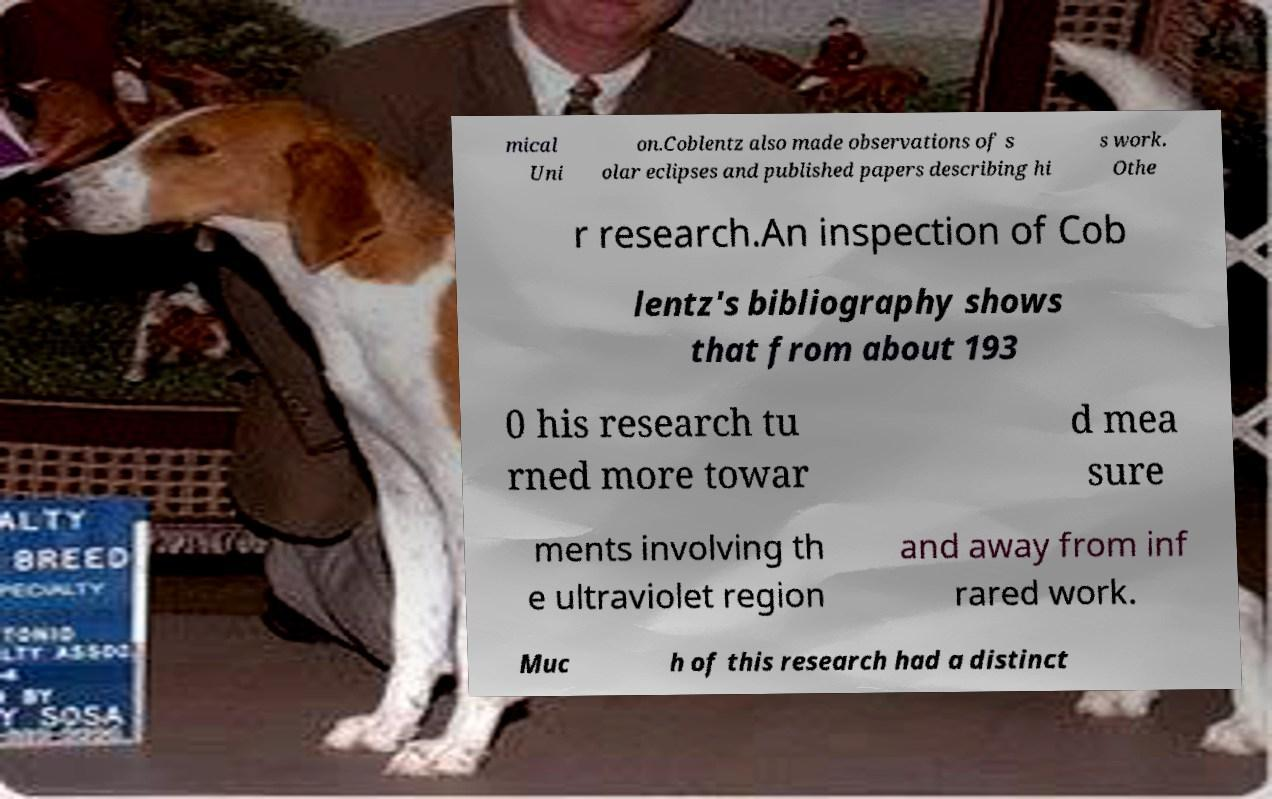Please identify and transcribe the text found in this image. mical Uni on.Coblentz also made observations of s olar eclipses and published papers describing hi s work. Othe r research.An inspection of Cob lentz's bibliography shows that from about 193 0 his research tu rned more towar d mea sure ments involving th e ultraviolet region and away from inf rared work. Muc h of this research had a distinct 